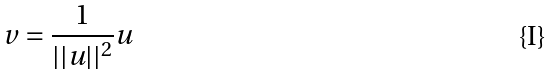Convert formula to latex. <formula><loc_0><loc_0><loc_500><loc_500>v = \frac { 1 } { | | u | | ^ { 2 } } u</formula> 